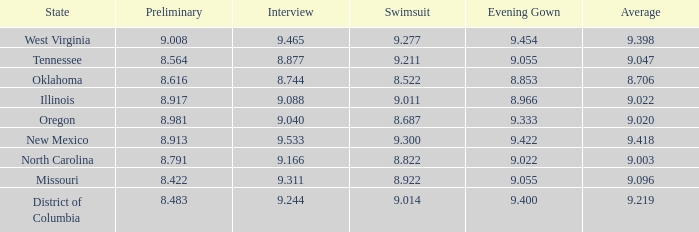Name the swuinsuit for oregon 8.687. 